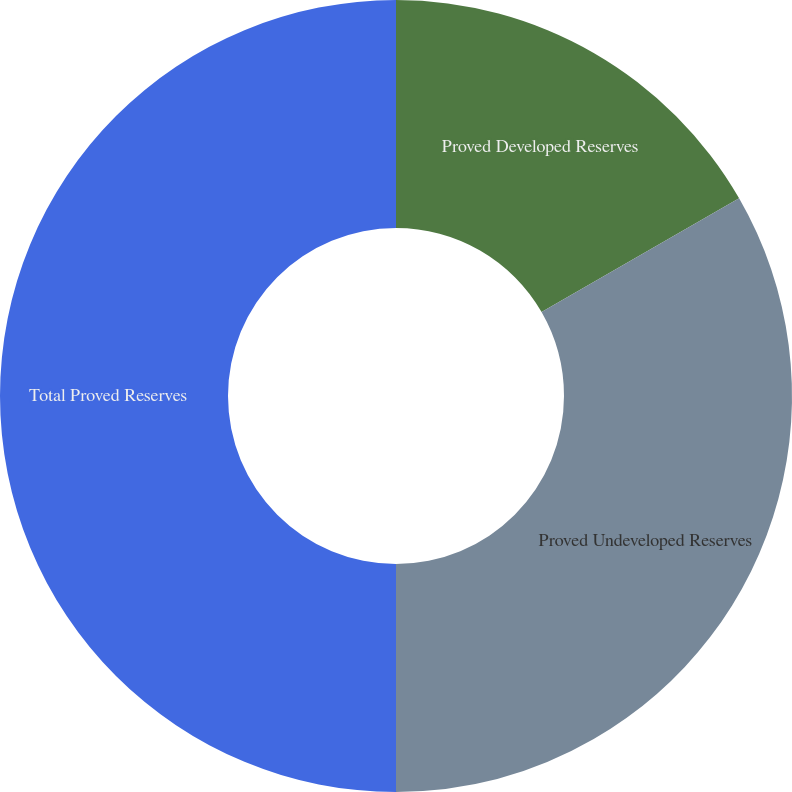<chart> <loc_0><loc_0><loc_500><loc_500><pie_chart><fcel>Proved Developed Reserves<fcel>Proved Undeveloped Reserves<fcel>Total Proved Reserves<nl><fcel>16.68%<fcel>33.32%<fcel>50.0%<nl></chart> 